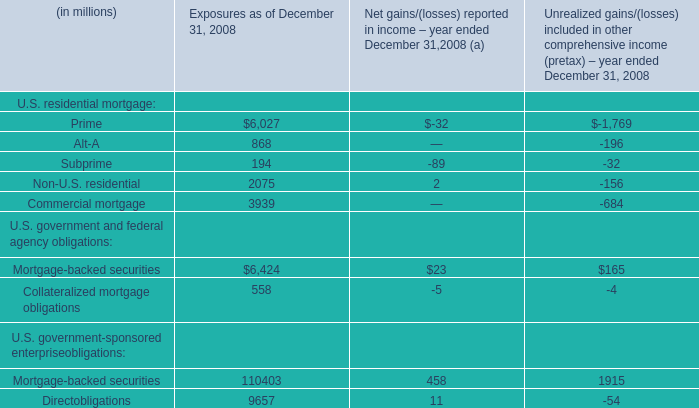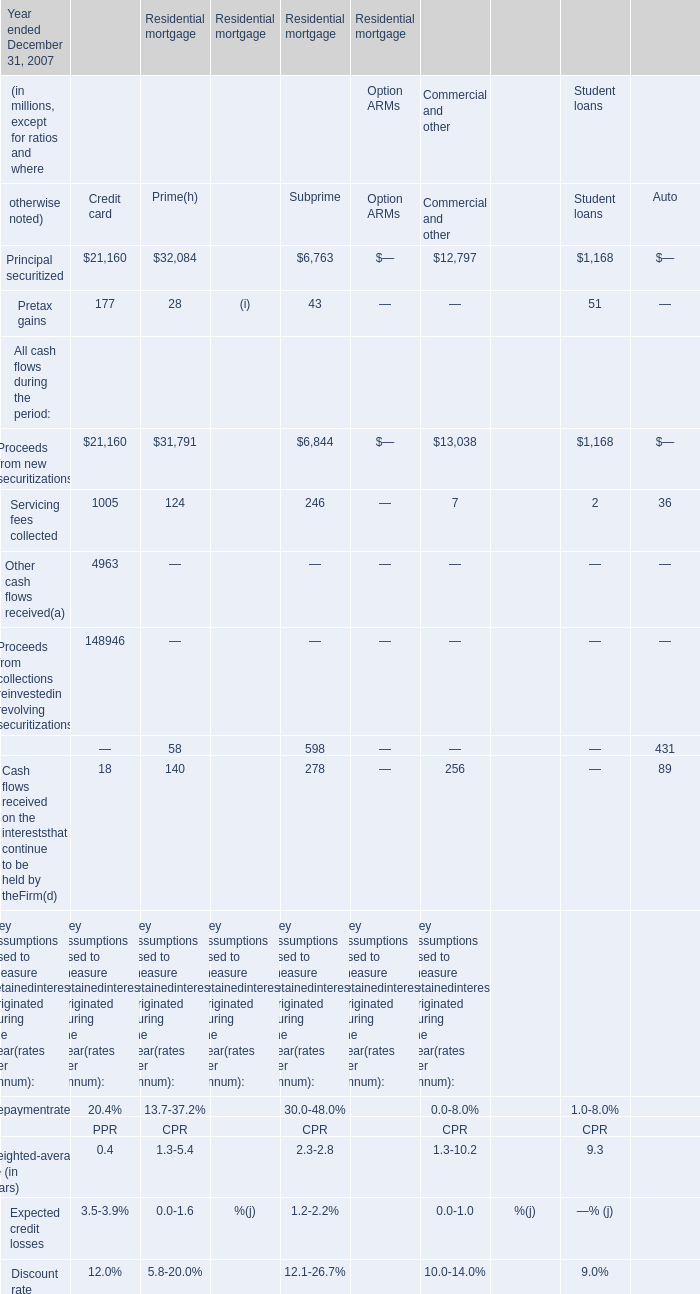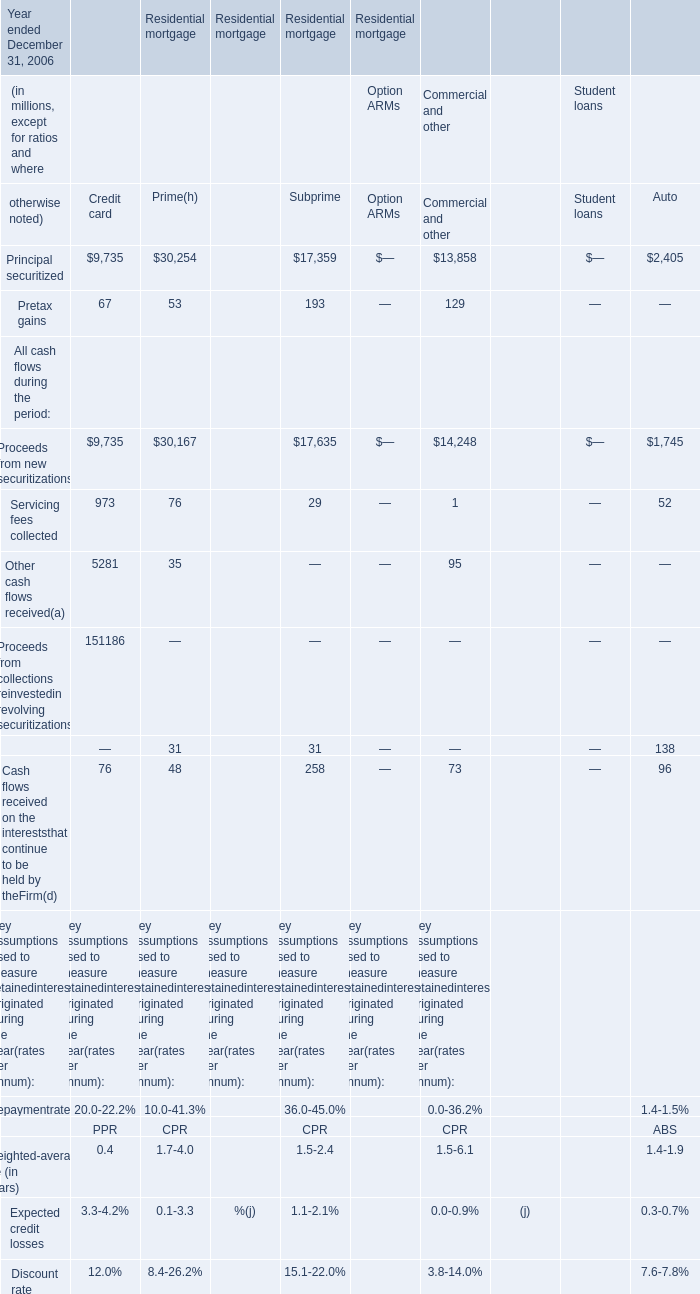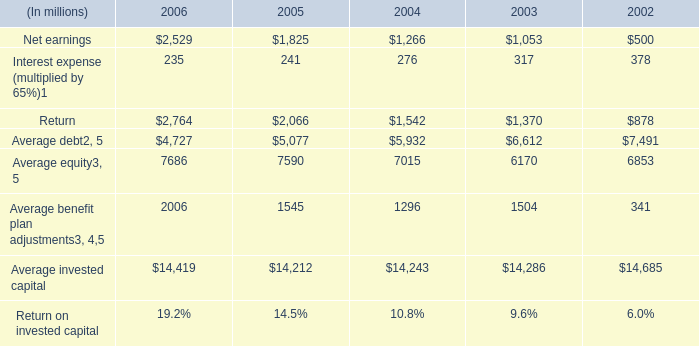What's the total value of all Subprime that are in the range of 0 and 500 in 2007? (in million) 
Computations: ((43 + 246) + 278)
Answer: 567.0. 